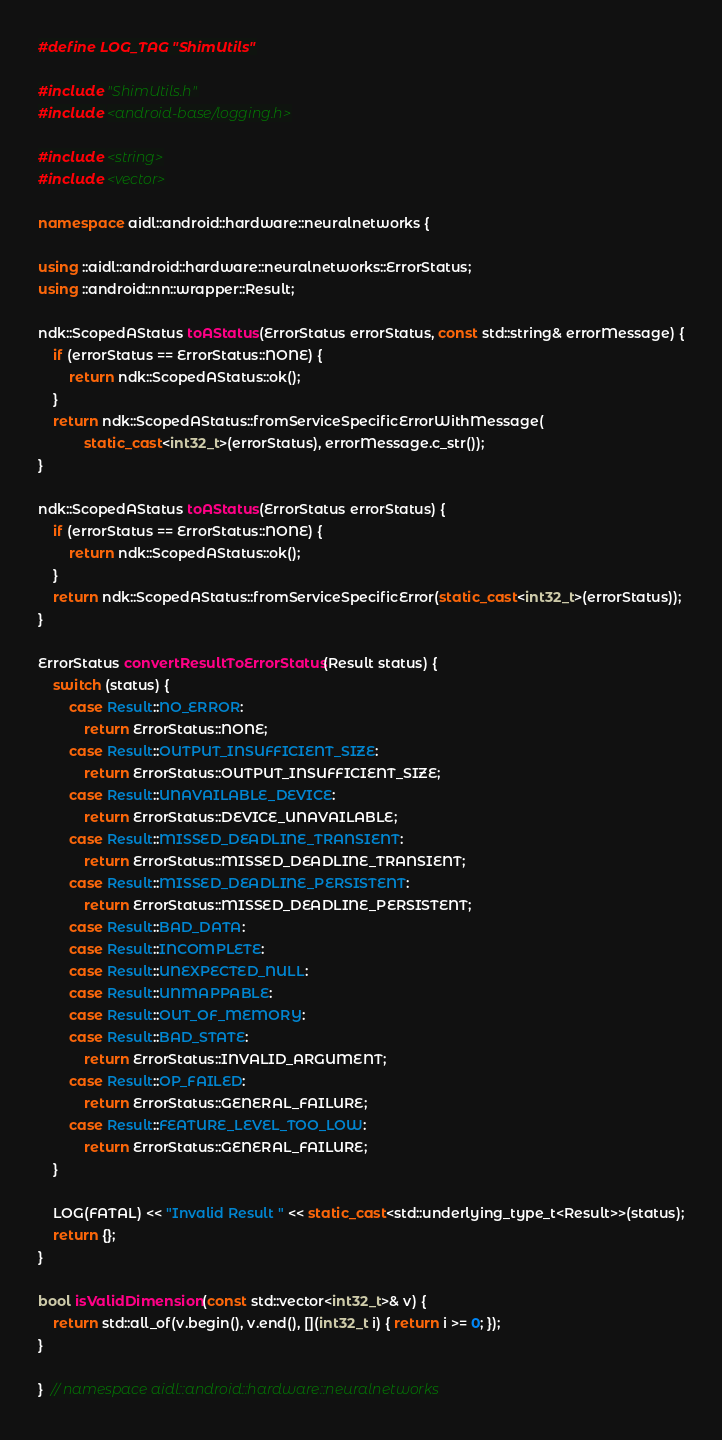<code> <loc_0><loc_0><loc_500><loc_500><_C++_>#define LOG_TAG "ShimUtils"

#include "ShimUtils.h"
#include <android-base/logging.h>

#include <string>
#include <vector>

namespace aidl::android::hardware::neuralnetworks {

using ::aidl::android::hardware::neuralnetworks::ErrorStatus;
using ::android::nn::wrapper::Result;

ndk::ScopedAStatus toAStatus(ErrorStatus errorStatus, const std::string& errorMessage) {
    if (errorStatus == ErrorStatus::NONE) {
        return ndk::ScopedAStatus::ok();
    }
    return ndk::ScopedAStatus::fromServiceSpecificErrorWithMessage(
            static_cast<int32_t>(errorStatus), errorMessage.c_str());
}

ndk::ScopedAStatus toAStatus(ErrorStatus errorStatus) {
    if (errorStatus == ErrorStatus::NONE) {
        return ndk::ScopedAStatus::ok();
    }
    return ndk::ScopedAStatus::fromServiceSpecificError(static_cast<int32_t>(errorStatus));
}

ErrorStatus convertResultToErrorStatus(Result status) {
    switch (status) {
        case Result::NO_ERROR:
            return ErrorStatus::NONE;
        case Result::OUTPUT_INSUFFICIENT_SIZE:
            return ErrorStatus::OUTPUT_INSUFFICIENT_SIZE;
        case Result::UNAVAILABLE_DEVICE:
            return ErrorStatus::DEVICE_UNAVAILABLE;
        case Result::MISSED_DEADLINE_TRANSIENT:
            return ErrorStatus::MISSED_DEADLINE_TRANSIENT;
        case Result::MISSED_DEADLINE_PERSISTENT:
            return ErrorStatus::MISSED_DEADLINE_PERSISTENT;
        case Result::BAD_DATA:
        case Result::INCOMPLETE:
        case Result::UNEXPECTED_NULL:
        case Result::UNMAPPABLE:
        case Result::OUT_OF_MEMORY:
        case Result::BAD_STATE:
            return ErrorStatus::INVALID_ARGUMENT;
        case Result::OP_FAILED:
            return ErrorStatus::GENERAL_FAILURE;
        case Result::FEATURE_LEVEL_TOO_LOW:
            return ErrorStatus::GENERAL_FAILURE;
    }

    LOG(FATAL) << "Invalid Result " << static_cast<std::underlying_type_t<Result>>(status);
    return {};
}

bool isValidDimension(const std::vector<int32_t>& v) {
    return std::all_of(v.begin(), v.end(), [](int32_t i) { return i >= 0; });
}

}  // namespace aidl::android::hardware::neuralnetworks
</code> 